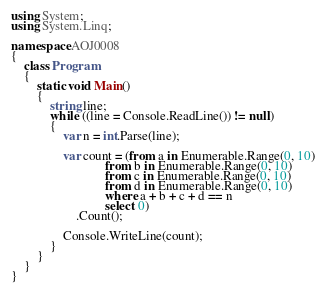<code> <loc_0><loc_0><loc_500><loc_500><_C#_>using System;
using System.Linq;

namespace AOJ0008
{
    class Program
    {
        static void Main()
        {
            string line;
            while ((line = Console.ReadLine()) != null)
            {
                var n = int.Parse(line);

                var count = (from a in Enumerable.Range(0, 10)
                             from b in Enumerable.Range(0, 10)
                             from c in Enumerable.Range(0, 10)
                             from d in Enumerable.Range(0, 10)
                             where a + b + c + d == n
                             select 0)
                    .Count();

                Console.WriteLine(count);
            }
        }
    }
}</code> 